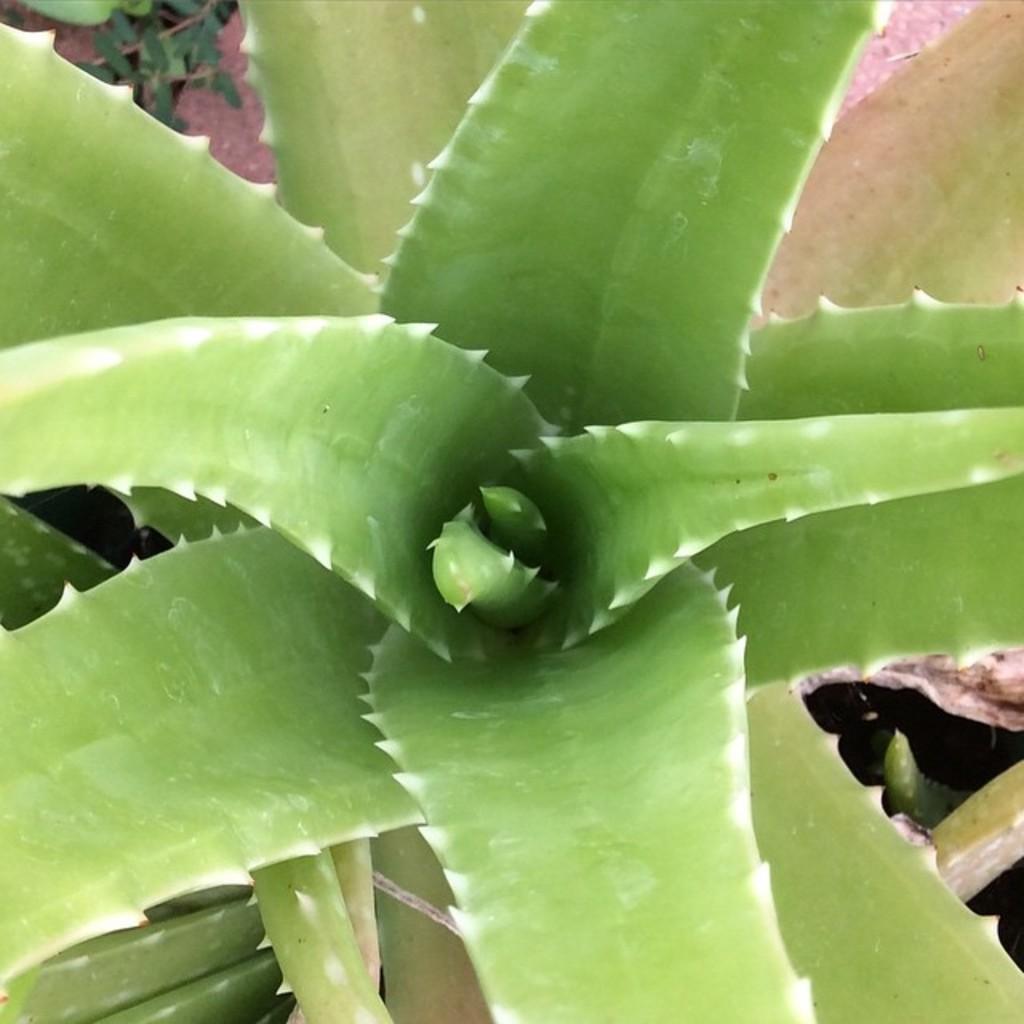Describe this image in one or two sentences. In this picture we can see Aloe Vera plants and in the background we can see leaves. 